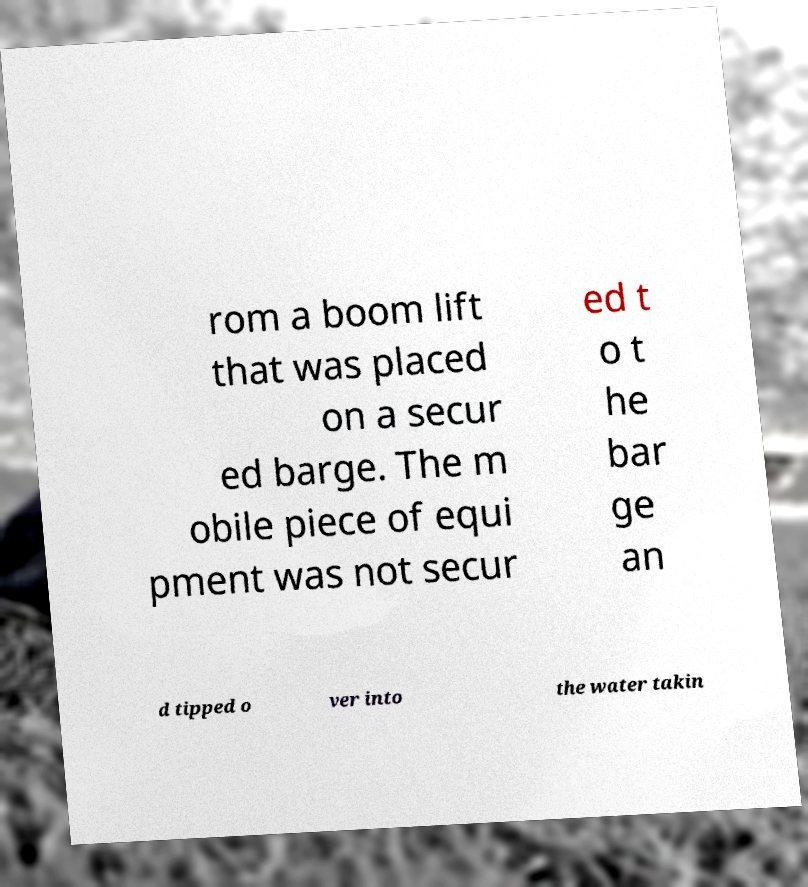Please identify and transcribe the text found in this image. rom a boom lift that was placed on a secur ed barge. The m obile piece of equi pment was not secur ed t o t he bar ge an d tipped o ver into the water takin 